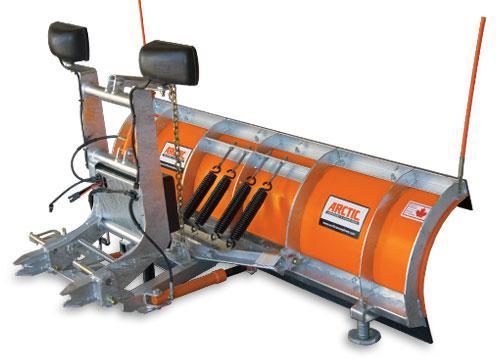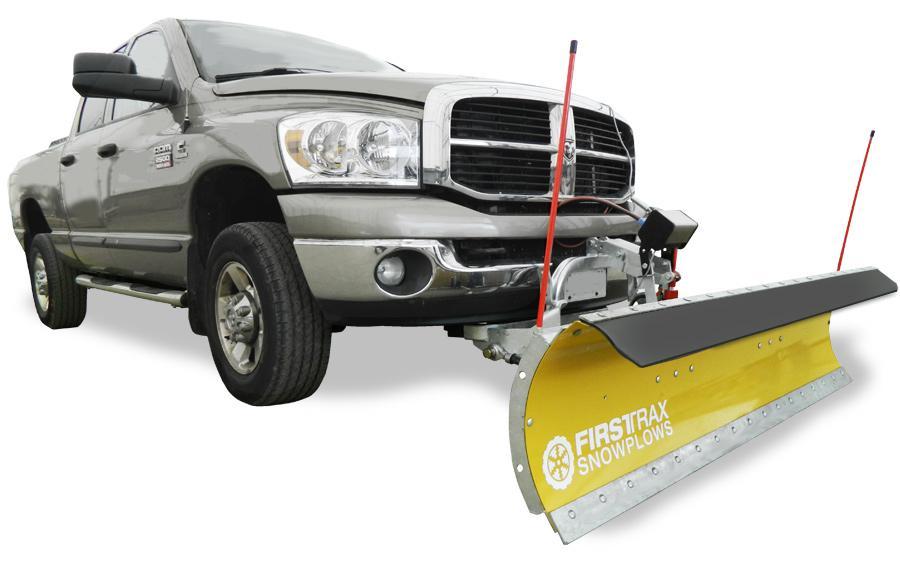The first image is the image on the left, the second image is the image on the right. Examine the images to the left and right. Is the description "One image shows an orange plow that is not attached to a vehicle." accurate? Answer yes or no. Yes. The first image is the image on the left, the second image is the image on the right. Analyze the images presented: Is the assertion "One image shows a complete angled side view of a pickup truck with a front snow blade, while a second image shows an unattached orange snow blade." valid? Answer yes or no. Yes. 